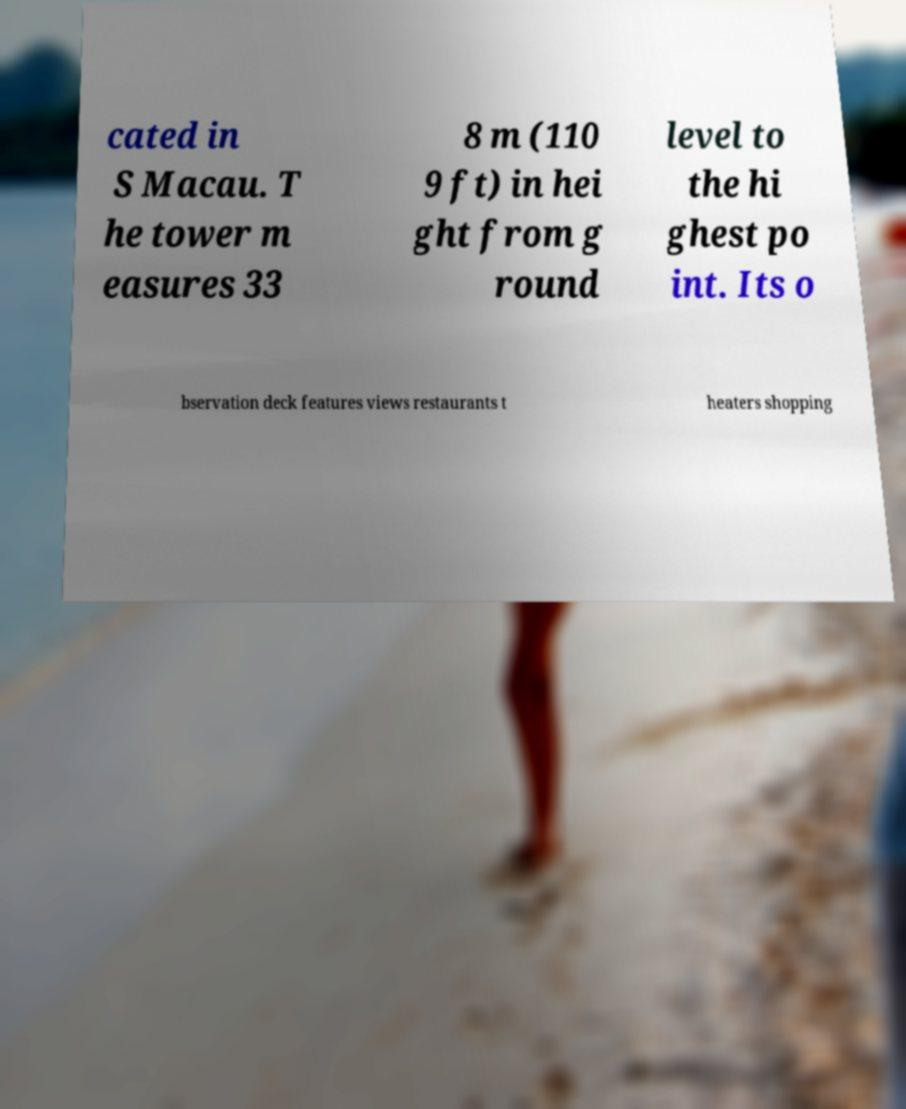Please read and relay the text visible in this image. What does it say? cated in S Macau. T he tower m easures 33 8 m (110 9 ft) in hei ght from g round level to the hi ghest po int. Its o bservation deck features views restaurants t heaters shopping 